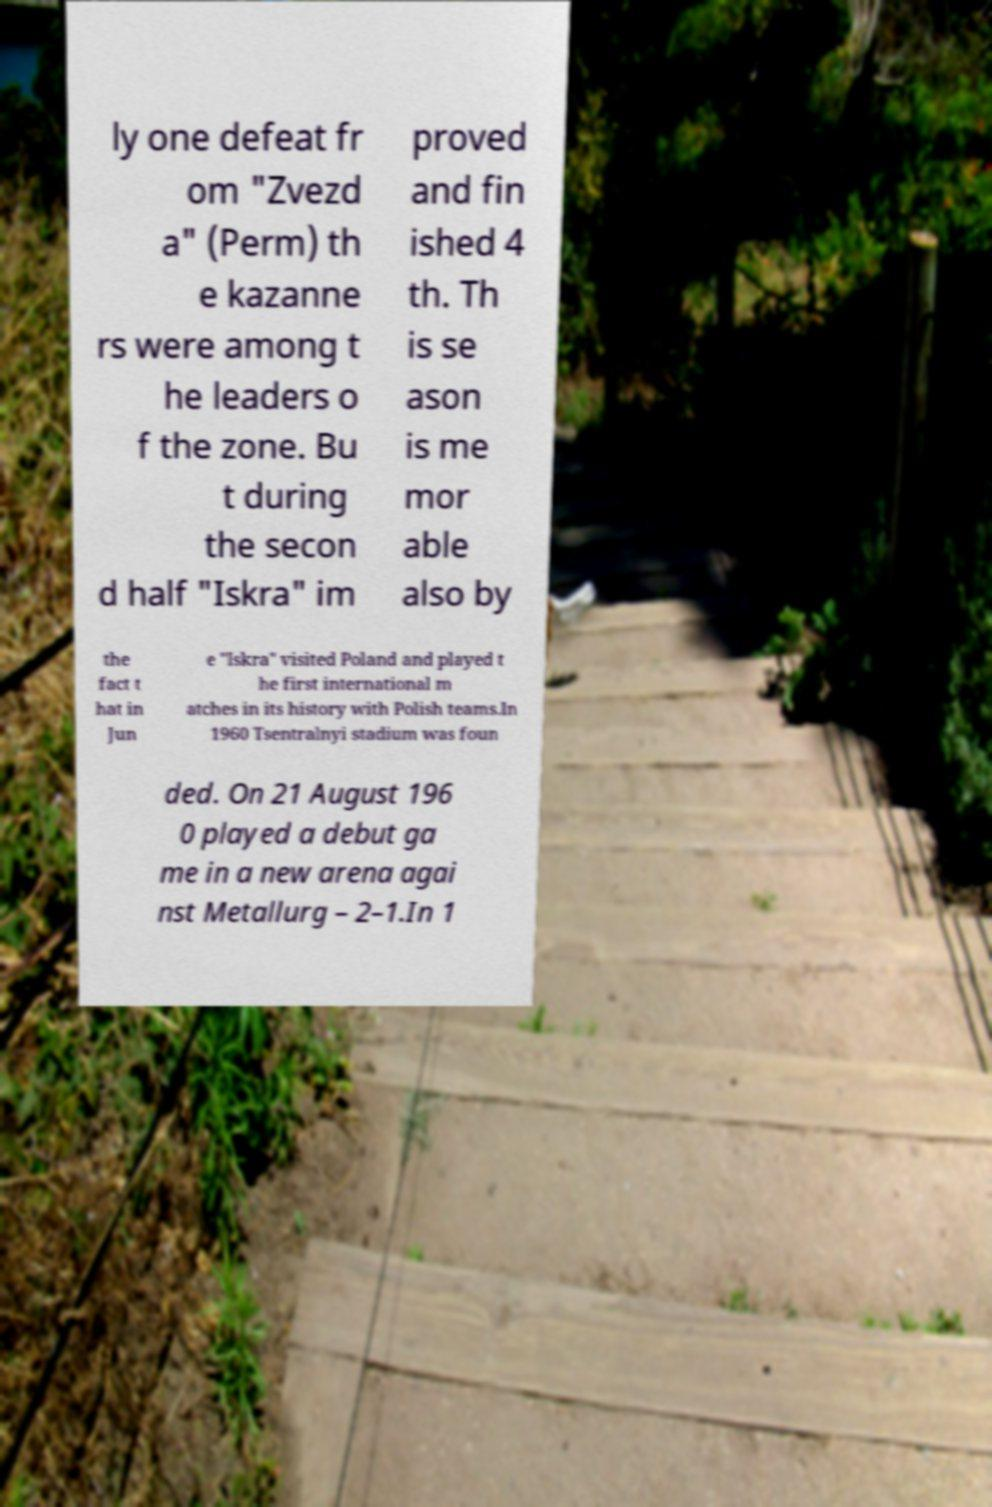Please identify and transcribe the text found in this image. ly one defeat fr om "Zvezd a" (Perm) th e kazanne rs were among t he leaders o f the zone. Bu t during the secon d half "Iskra" im proved and fin ished 4 th. Th is se ason is me mor able also by the fact t hat in Jun e "Iskra" visited Poland and played t he first international m atches in its history with Polish teams.In 1960 Tsentralnyi stadium was foun ded. On 21 August 196 0 played a debut ga me in a new arena agai nst Metallurg – 2–1.In 1 